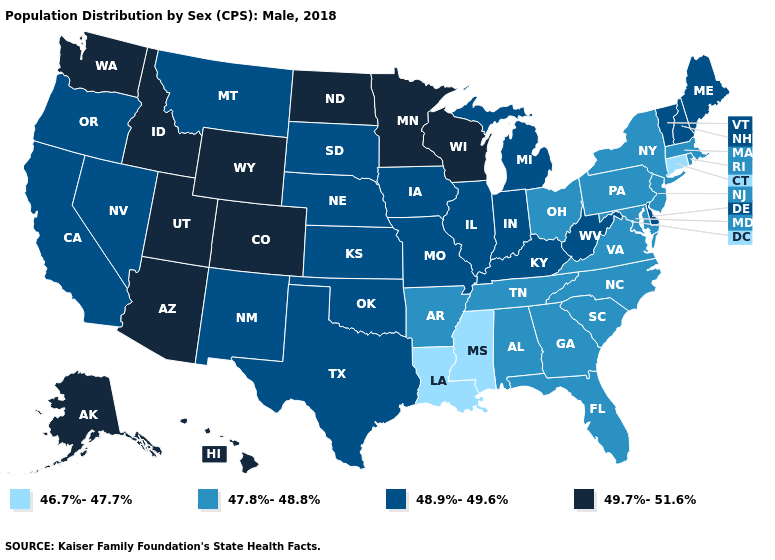Does Nevada have the highest value in the West?
Keep it brief. No. What is the value of Louisiana?
Keep it brief. 46.7%-47.7%. What is the value of Pennsylvania?
Answer briefly. 47.8%-48.8%. Does Idaho have a higher value than New York?
Give a very brief answer. Yes. What is the value of Colorado?
Answer briefly. 49.7%-51.6%. Name the states that have a value in the range 47.8%-48.8%?
Quick response, please. Alabama, Arkansas, Florida, Georgia, Maryland, Massachusetts, New Jersey, New York, North Carolina, Ohio, Pennsylvania, Rhode Island, South Carolina, Tennessee, Virginia. What is the value of Minnesota?
Write a very short answer. 49.7%-51.6%. What is the highest value in the USA?
Short answer required. 49.7%-51.6%. What is the value of Minnesota?
Quick response, please. 49.7%-51.6%. What is the value of Colorado?
Give a very brief answer. 49.7%-51.6%. Name the states that have a value in the range 47.8%-48.8%?
Answer briefly. Alabama, Arkansas, Florida, Georgia, Maryland, Massachusetts, New Jersey, New York, North Carolina, Ohio, Pennsylvania, Rhode Island, South Carolina, Tennessee, Virginia. Does Connecticut have the lowest value in the Northeast?
Short answer required. Yes. What is the lowest value in the MidWest?
Write a very short answer. 47.8%-48.8%. Which states hav the highest value in the MidWest?
Be succinct. Minnesota, North Dakota, Wisconsin. What is the highest value in states that border South Carolina?
Answer briefly. 47.8%-48.8%. 